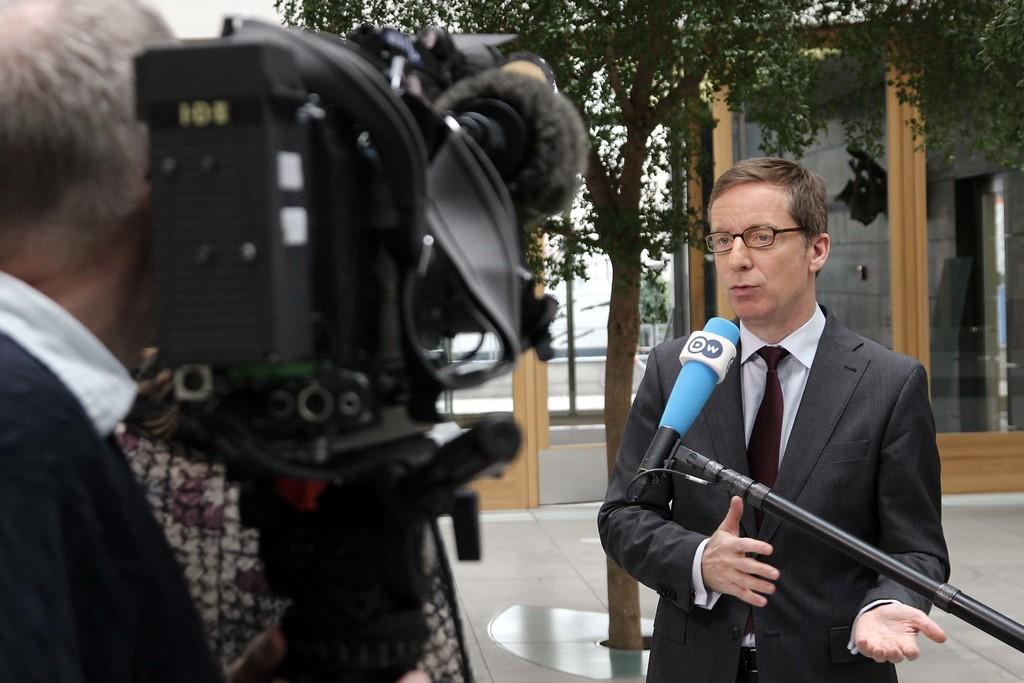Describe this image in one or two sentences. Here this man is talking. He is wearing a spectacle, suit, and tie. This is the mic. This is the camera. On the left hand side, this man is holding this camera. In the background, this is the tree. This is the glass. This is the floor 